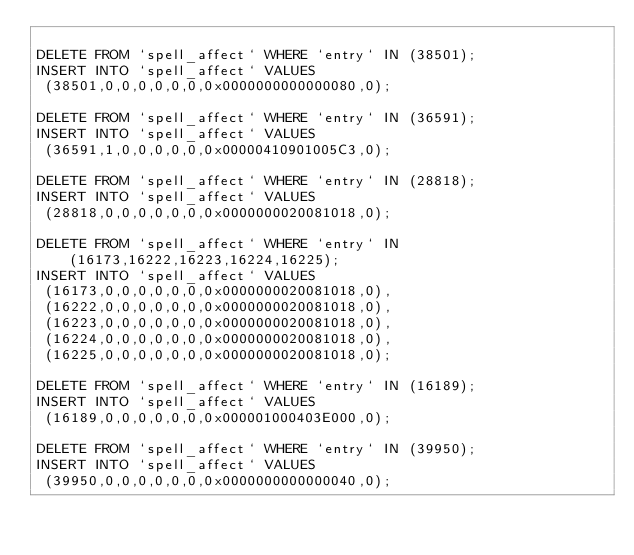Convert code to text. <code><loc_0><loc_0><loc_500><loc_500><_SQL_>
DELETE FROM `spell_affect` WHERE `entry` IN (38501);
INSERT INTO `spell_affect` VALUES
 (38501,0,0,0,0,0,0,0x0000000000000080,0);

DELETE FROM `spell_affect` WHERE `entry` IN (36591);
INSERT INTO `spell_affect` VALUES
 (36591,1,0,0,0,0,0,0x00000410901005C3,0);

DELETE FROM `spell_affect` WHERE `entry` IN (28818);
INSERT INTO `spell_affect` VALUES
 (28818,0,0,0,0,0,0,0x0000000020081018,0);

DELETE FROM `spell_affect` WHERE `entry` IN (16173,16222,16223,16224,16225);
INSERT INTO `spell_affect` VALUES
 (16173,0,0,0,0,0,0,0x0000000020081018,0),
 (16222,0,0,0,0,0,0,0x0000000020081018,0),
 (16223,0,0,0,0,0,0,0x0000000020081018,0),
 (16224,0,0,0,0,0,0,0x0000000020081018,0),
 (16225,0,0,0,0,0,0,0x0000000020081018,0);

DELETE FROM `spell_affect` WHERE `entry` IN (16189);
INSERT INTO `spell_affect` VALUES
 (16189,0,0,0,0,0,0,0x000001000403E000,0);

DELETE FROM `spell_affect` WHERE `entry` IN (39950);
INSERT INTO `spell_affect` VALUES
 (39950,0,0,0,0,0,0,0x0000000000000040,0);


</code> 